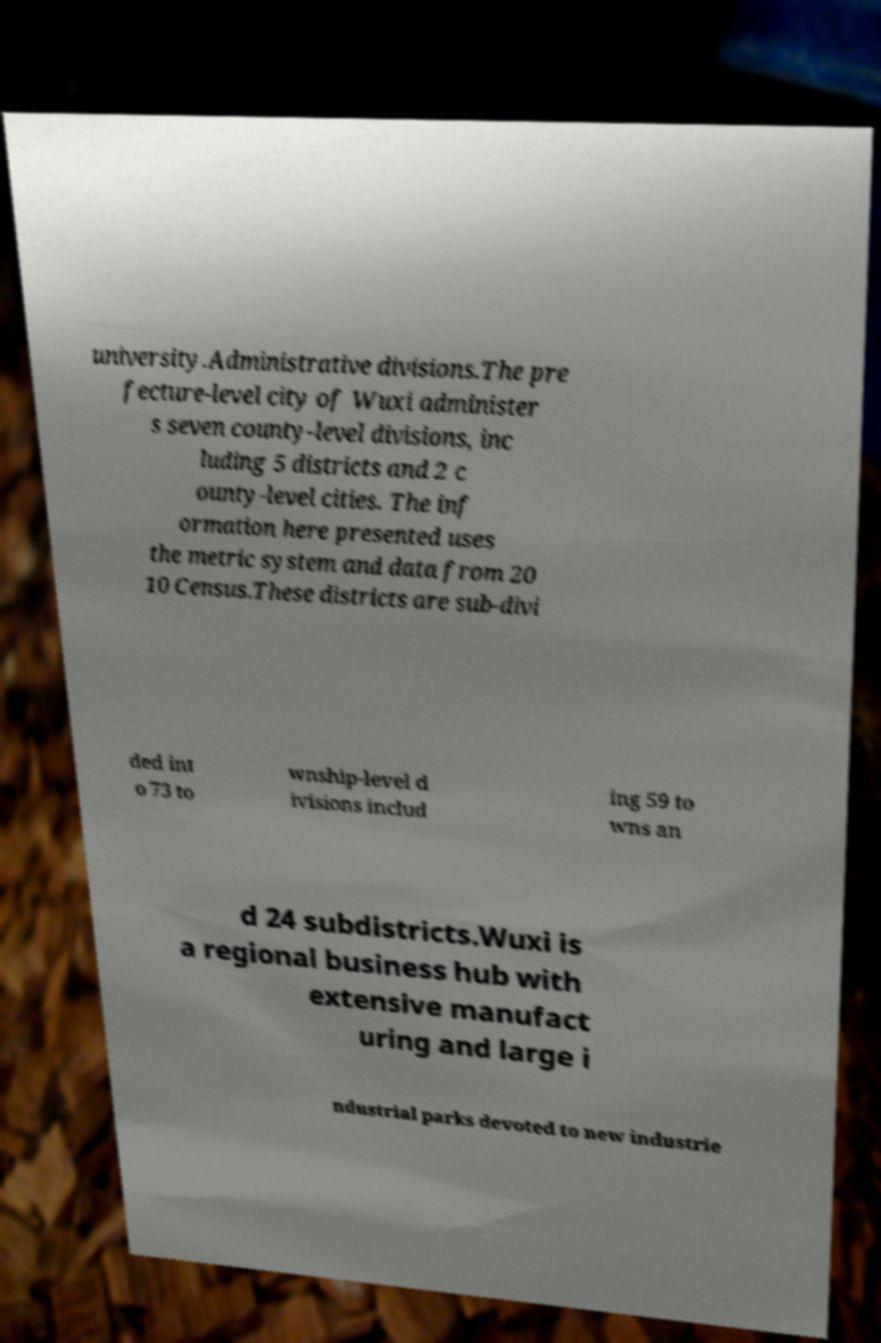What messages or text are displayed in this image? I need them in a readable, typed format. university.Administrative divisions.The pre fecture-level city of Wuxi administer s seven county-level divisions, inc luding 5 districts and 2 c ounty-level cities. The inf ormation here presented uses the metric system and data from 20 10 Census.These districts are sub-divi ded int o 73 to wnship-level d ivisions includ ing 59 to wns an d 24 subdistricts.Wuxi is a regional business hub with extensive manufact uring and large i ndustrial parks devoted to new industrie 